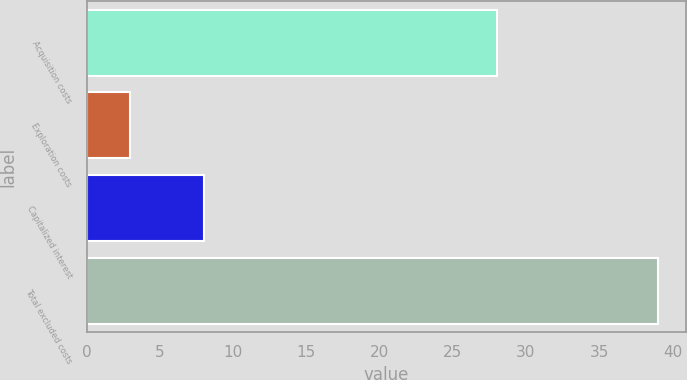Convert chart. <chart><loc_0><loc_0><loc_500><loc_500><bar_chart><fcel>Acquisition costs<fcel>Exploration costs<fcel>Capitalized interest<fcel>Total excluded costs<nl><fcel>28<fcel>3<fcel>8<fcel>39<nl></chart> 